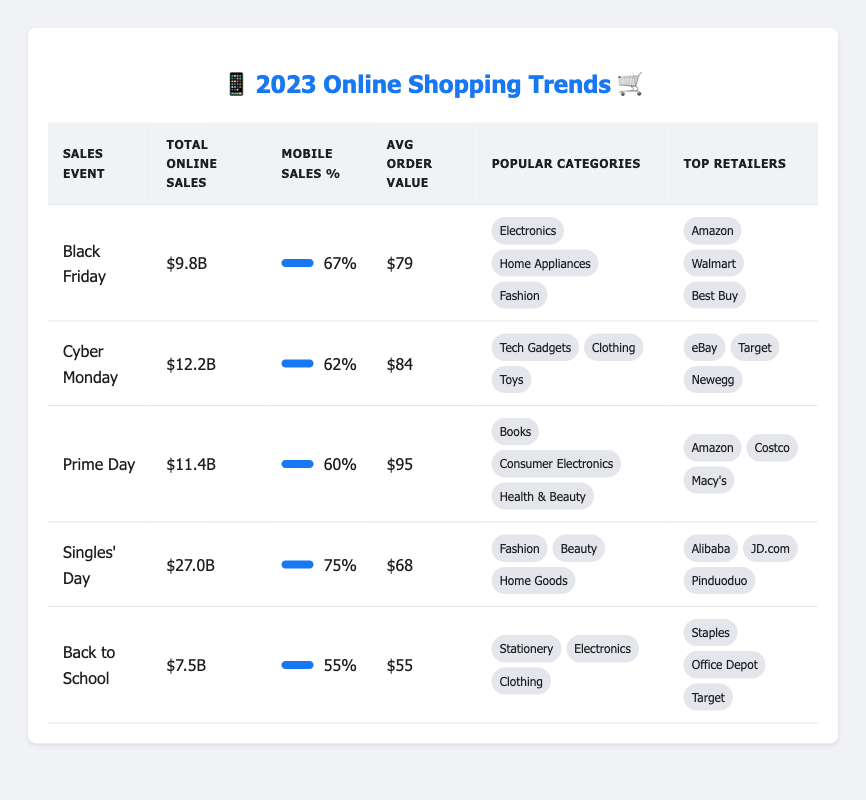What was the total online sales for Cyber Monday in 2023? The table shows that the total online sales for Cyber Monday in 2023 is listed as $12.2B.
Answer: $12.2B Which sales event had the highest mobile sales percentage? By comparing the percentages listed under "Mobile Sales %", Singles' Day has the highest at 75%.
Answer: 75% What are the most popular categories during Black Friday? The table states that the most popular categories during Black Friday are Electronics, Home Appliances, and Fashion.
Answer: Electronics, Home Appliances, Fashion How does the average order value of Prime Day compare to Back to School? The average order value for Prime Day is $95, while Back to School is $55. The difference is $40, indicating that Prime Day has a higher average order value.
Answer: $40 difference Did more people shop online through mobile devices on Singles' Day compared to Back to School? Yes, the mobile sales percentage for Singles' Day is 75%, while for Back to School it is 55%. Therefore, more people shopped via mobile on Singles' Day.
Answer: Yes What is the total online sales for all events combined? To find the total, we add the sales from each event: $9.8B (Black Friday) + $12.2B (Cyber Monday) + $11.4B (Prime Day) + $27.0B (Singles' Day) + $7.5B (Back to School) = $67.9B.
Answer: $67.9B Which retailer was present in both Black Friday and Prime Day? The top retailer for Black Friday is Amazon, and it is also listed as a top retailer for Prime Day.
Answer: Amazon What is the average mobile sales percentage across all events? The total mobile sales percentages are 67 + 62 + 60 + 75 + 55 = 319. Dividing by the number of events (5) gives us an average of 63.8%.
Answer: 63.8% 